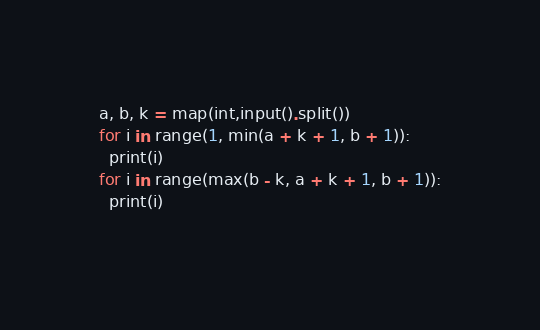Convert code to text. <code><loc_0><loc_0><loc_500><loc_500><_Python_>a, b, k = map(int,input().split())
for i in range(1, min(a + k + 1, b + 1)):
  print(i)
for i in range(max(b - k, a + k + 1, b + 1)):
  print(i)
  </code> 